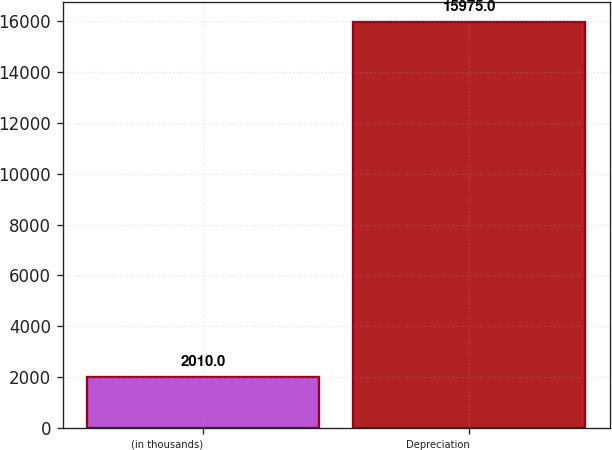Convert chart. <chart><loc_0><loc_0><loc_500><loc_500><bar_chart><fcel>(in thousands)<fcel>Depreciation<nl><fcel>2010<fcel>15975<nl></chart> 